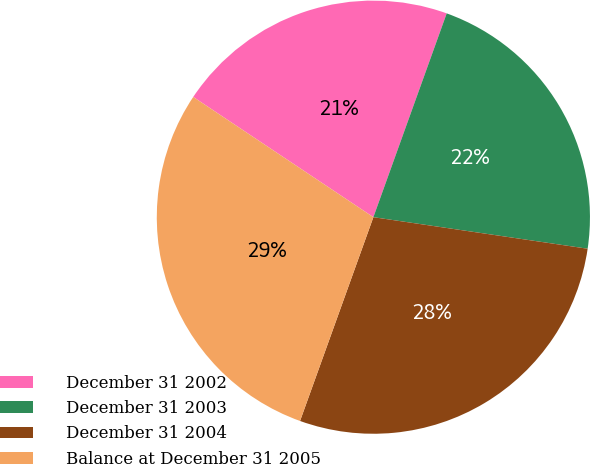<chart> <loc_0><loc_0><loc_500><loc_500><pie_chart><fcel>December 31 2002<fcel>December 31 2003<fcel>December 31 2004<fcel>Balance at December 31 2005<nl><fcel>21.13%<fcel>21.83%<fcel>28.17%<fcel>28.87%<nl></chart> 